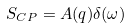Convert formula to latex. <formula><loc_0><loc_0><loc_500><loc_500>S _ { C P } = A ( { q } ) \delta ( \omega )</formula> 